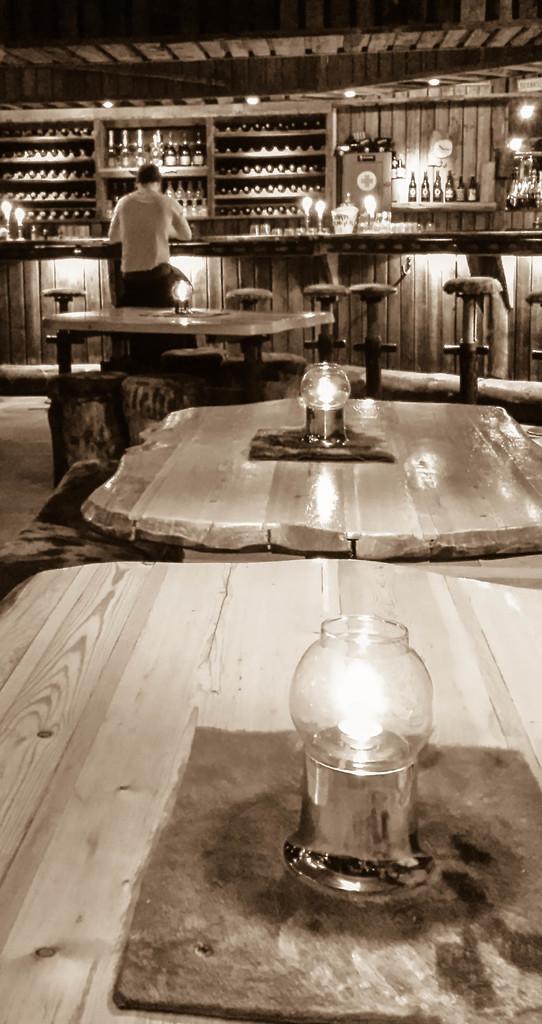Describe this image in one or two sentences. In the image we can see a person sitting and wearing clothes. Here we can see the tables and on the tables we can see the lamps. Here we can see stools and there are many bottles kept on the shelves. We can even see the lights and the floor. 